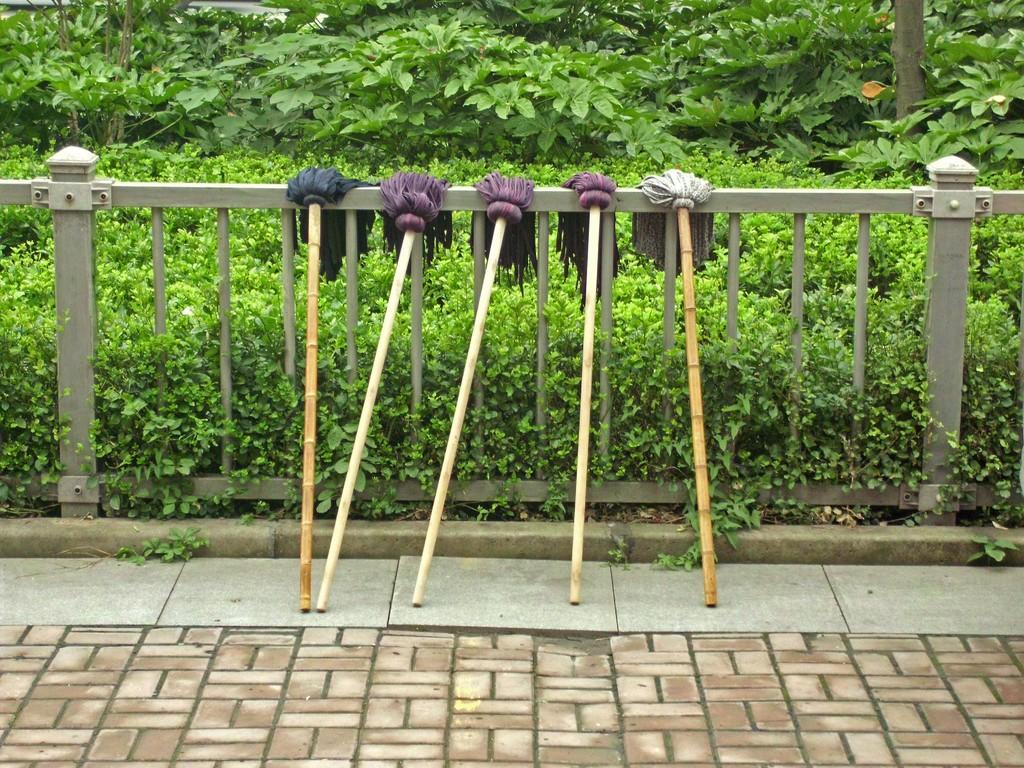What objects are on the railing in the image? There are mops on the railing in the image. What else can be seen in the image besides the mops? There are plants present in the image. What type of fang can be seen in the image? There is no fang present in the image. What kind of jewel is displayed on the plants in the image? There are no jewels present in the image; it only features mops and plants. 